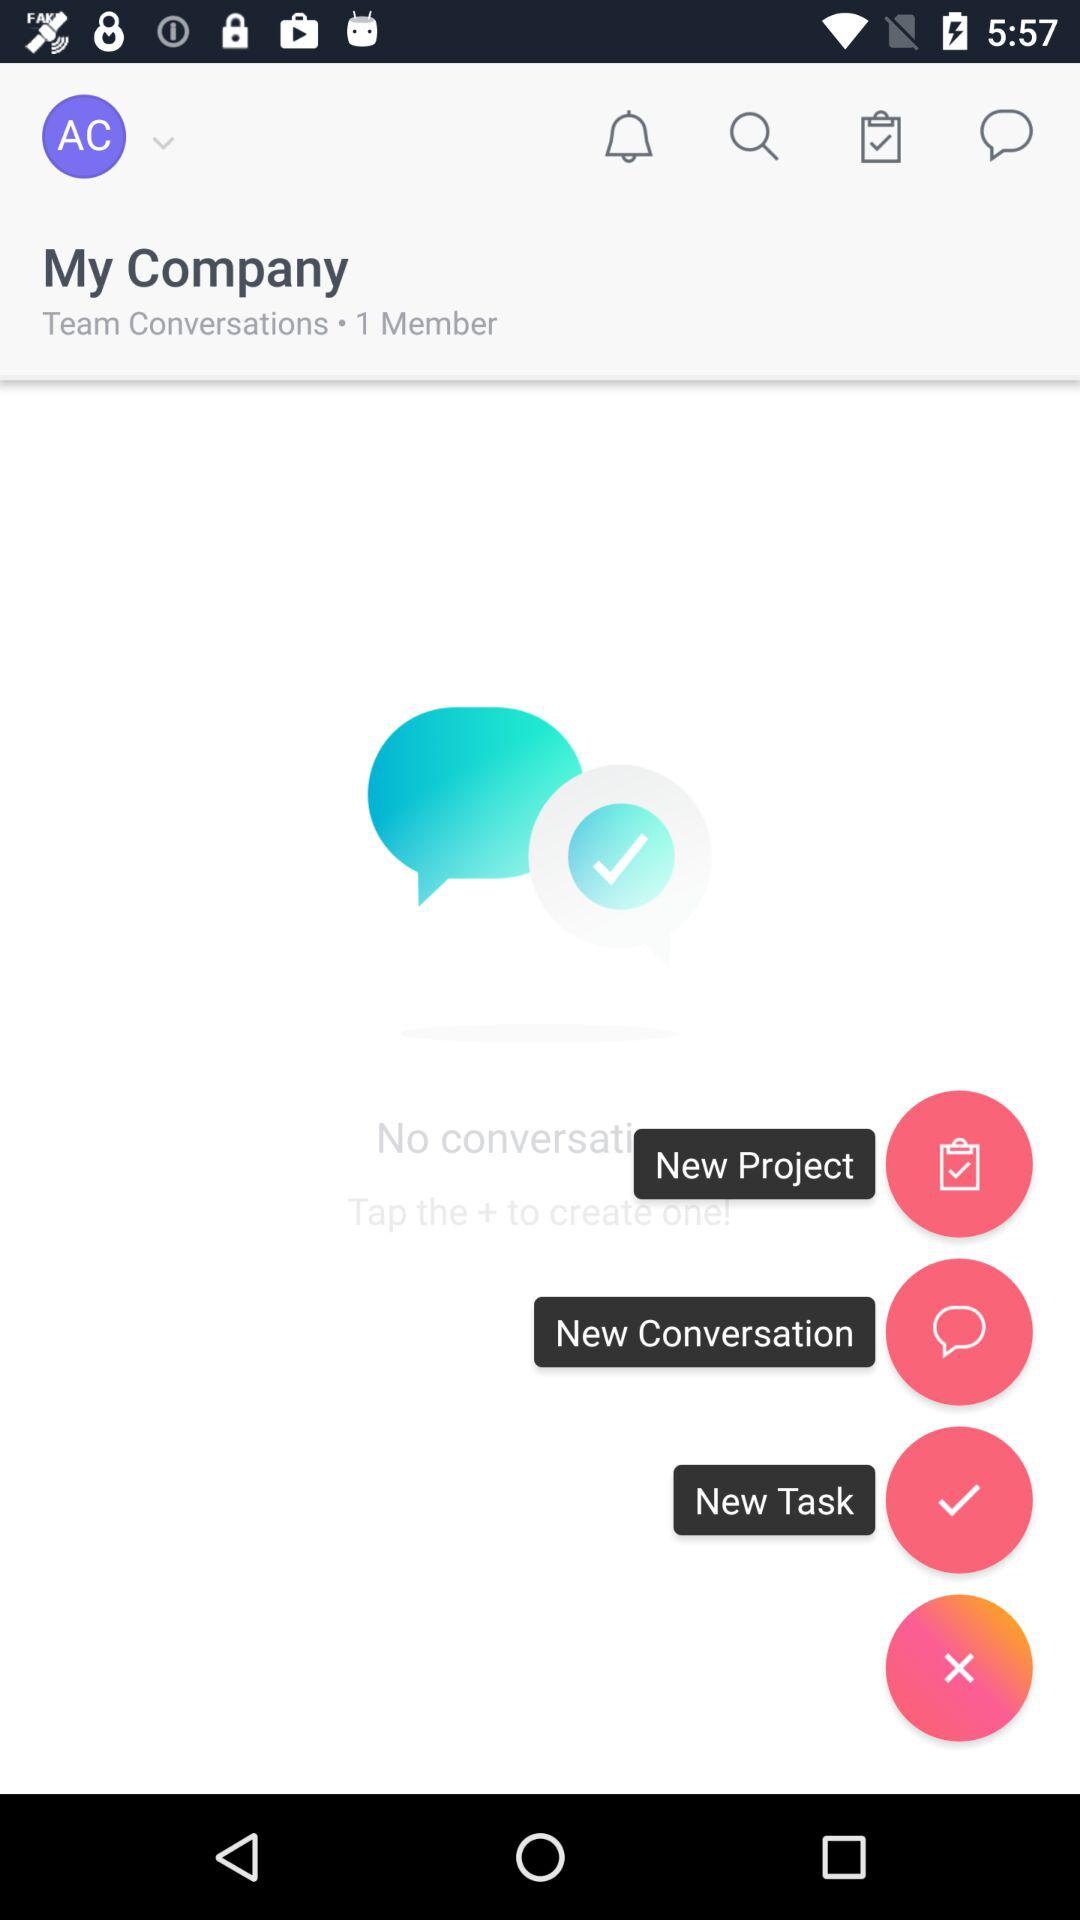How many new projects are there?
When the provided information is insufficient, respond with <no answer>. <no answer> 